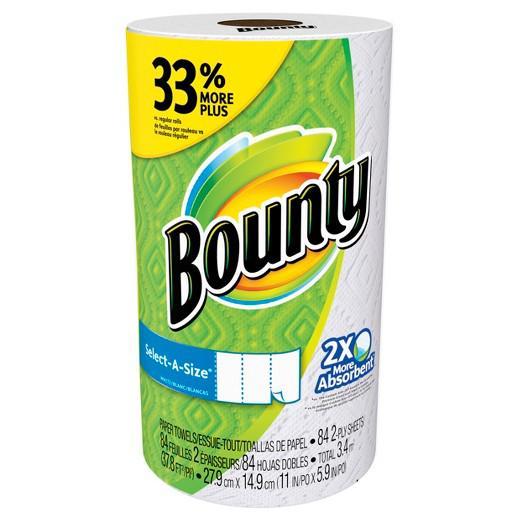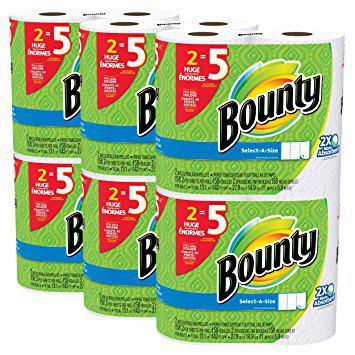The first image is the image on the left, the second image is the image on the right. Examine the images to the left and right. Is the description "The color scheme on the paper towel products on the left and right is primarily green, and each image contains exactly one multipack of paper towels." accurate? Answer yes or no. No. The first image is the image on the left, the second image is the image on the right. Assess this claim about the two images: "There are more than thirteen rolls.". Correct or not? Answer yes or no. No. 